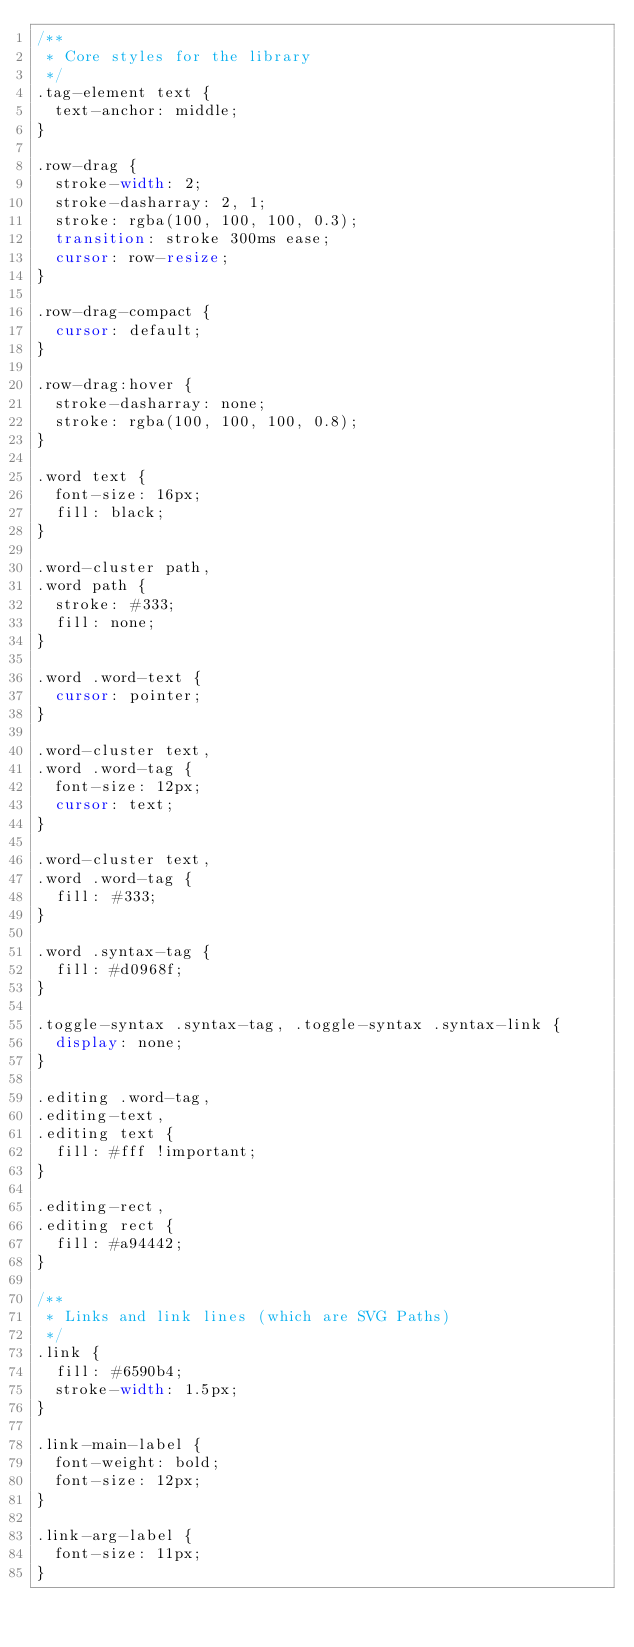Convert code to text. <code><loc_0><loc_0><loc_500><loc_500><_CSS_>/**
 * Core styles for the library
 */
.tag-element text {
  text-anchor: middle;
}

.row-drag {
  stroke-width: 2;
  stroke-dasharray: 2, 1;
  stroke: rgba(100, 100, 100, 0.3);
  transition: stroke 300ms ease;
  cursor: row-resize;
}

.row-drag-compact {
  cursor: default;
}

.row-drag:hover {
  stroke-dasharray: none;
  stroke: rgba(100, 100, 100, 0.8);
}

.word text {
  font-size: 16px;
  fill: black;
}

.word-cluster path,
.word path {
  stroke: #333;
  fill: none;
}

.word .word-text {
  cursor: pointer;
}

.word-cluster text,
.word .word-tag {
  font-size: 12px;
  cursor: text;
}

.word-cluster text,
.word .word-tag {
  fill: #333;
}

.word .syntax-tag {
  fill: #d0968f;
}

.toggle-syntax .syntax-tag, .toggle-syntax .syntax-link {
  display: none;
}

.editing .word-tag,
.editing-text,
.editing text {
  fill: #fff !important;
}

.editing-rect,
.editing rect {
  fill: #a94442;
}

/**
 * Links and link lines (which are SVG Paths)
 */
.link {
  fill: #6590b4;
  stroke-width: 1.5px;
}

.link-main-label {
  font-weight: bold;
  font-size: 12px;
}

.link-arg-label {
  font-size: 11px;
}
</code> 